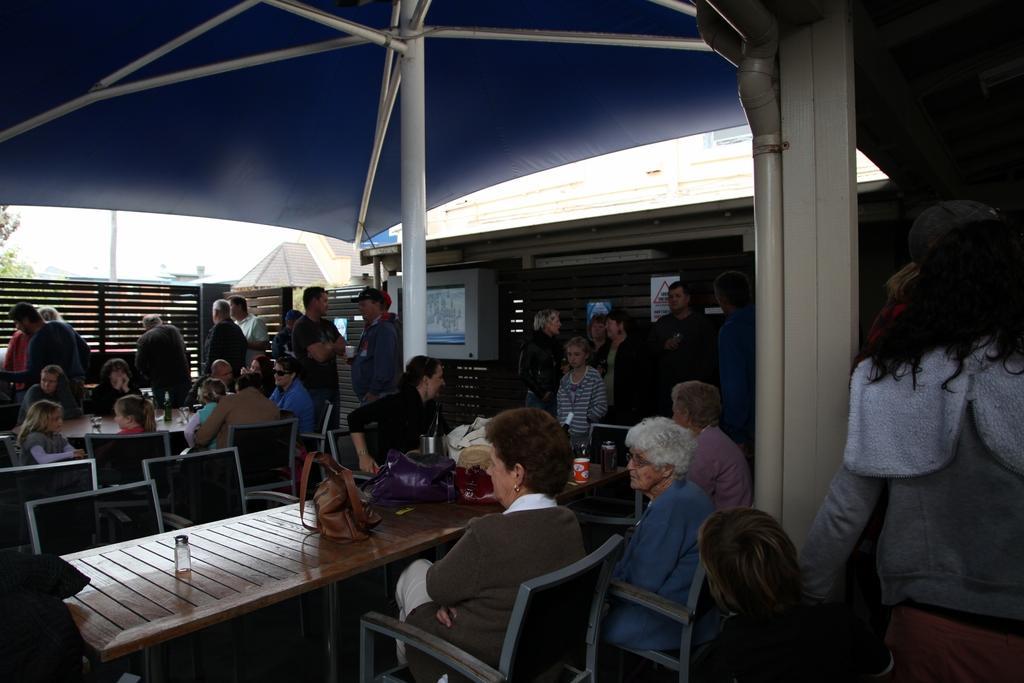How would you summarize this image in a sentence or two? In this image i can see few people standing and few people sitting on chairs in front of a table. On the table i can see few bottles, few glasses and few bags. In the background i can see a gate, the tent, few buildings, the sky and few trees. 